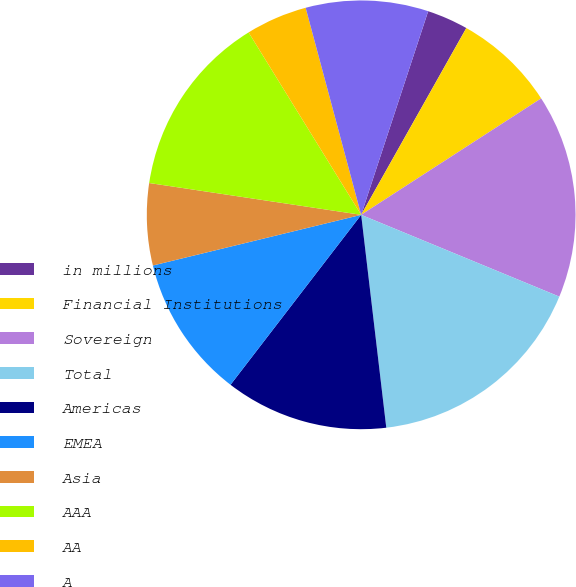Convert chart to OTSL. <chart><loc_0><loc_0><loc_500><loc_500><pie_chart><fcel>in millions<fcel>Financial Institutions<fcel>Sovereign<fcel>Total<fcel>Americas<fcel>EMEA<fcel>Asia<fcel>AAA<fcel>AA<fcel>A<nl><fcel>3.1%<fcel>7.7%<fcel>15.37%<fcel>16.9%<fcel>12.3%<fcel>10.77%<fcel>6.17%<fcel>13.83%<fcel>4.63%<fcel>9.23%<nl></chart> 